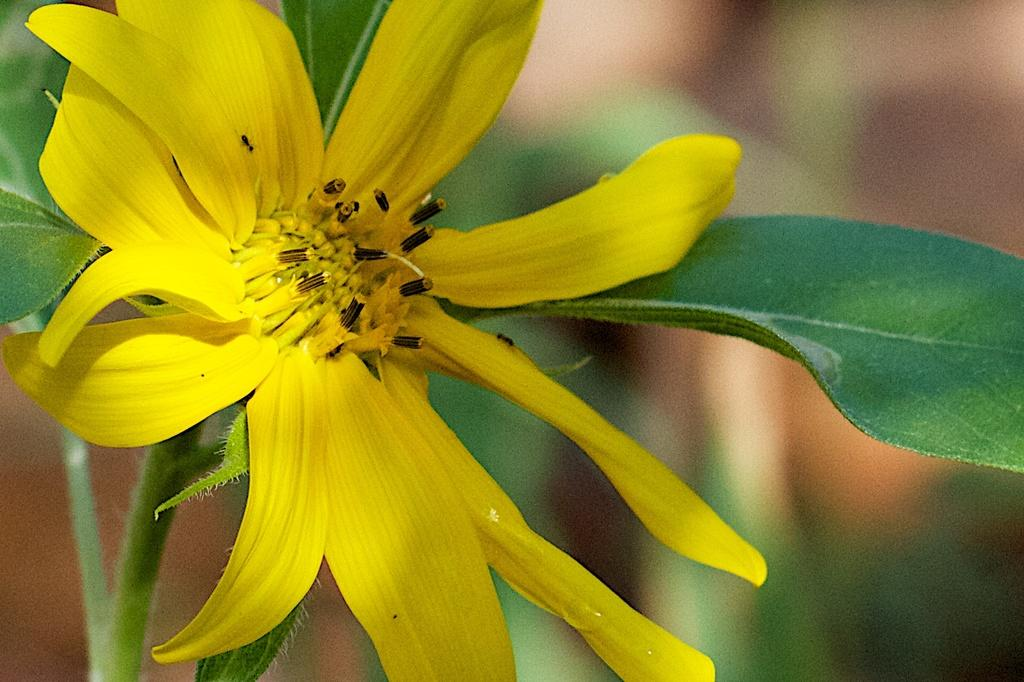What is the main subject of the image? The main subject of the image is a plant. What specific features can be observed on the plant? The plant has a flower and leaves. Can you describe the background of the image? The background of the image is blurry. How many apples are hanging from the plant in the image? There are no apples present in the image; the plant has a flower and leaves. What type of oil can be seen dripping from the flower in the image? There is no oil present in the image; the plant has a flower and leaves. 